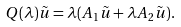<formula> <loc_0><loc_0><loc_500><loc_500>Q ( \lambda ) \tilde { u } = \lambda ( A _ { 1 } \tilde { u } + \lambda A _ { 2 } \tilde { u } ) .</formula> 